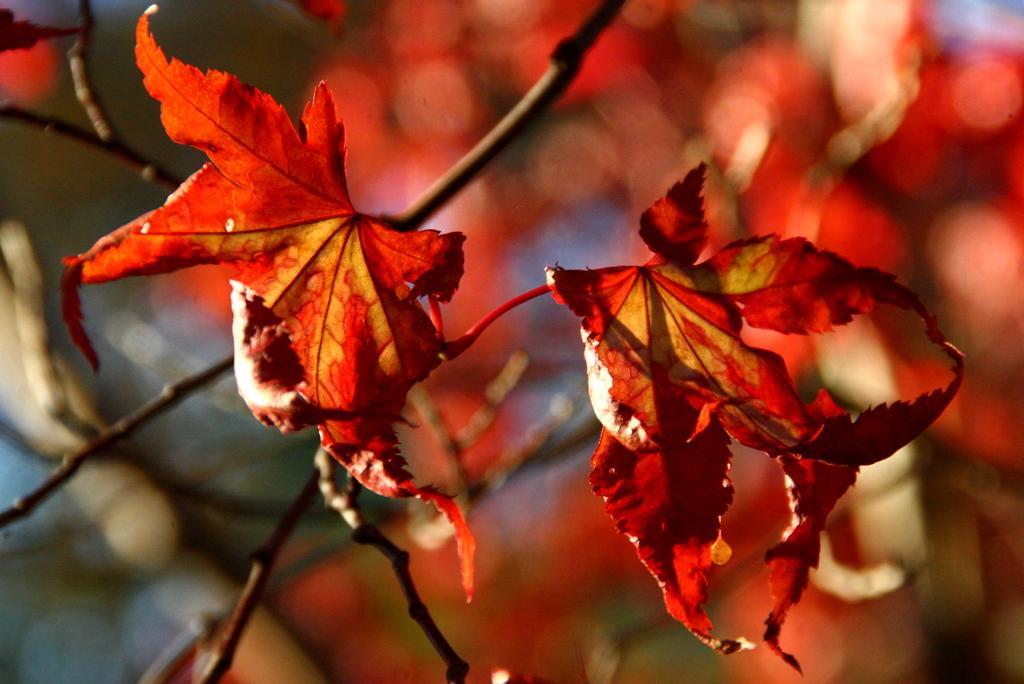Can you describe this image briefly? In this picture I can observe red color leaves to the tree. The background is completely blurred. 